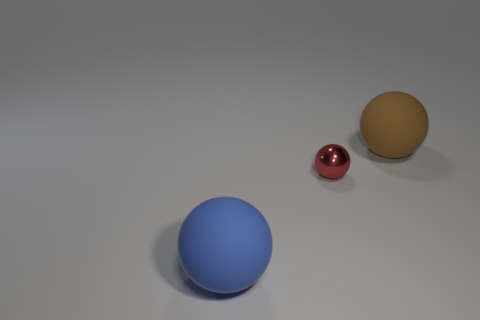Add 1 large blue matte blocks. How many objects exist? 4 Add 3 large brown things. How many large brown things are left? 4 Add 3 gray matte cylinders. How many gray matte cylinders exist? 3 Subtract 0 gray balls. How many objects are left? 3 Subtract all blue rubber things. Subtract all large gray matte cubes. How many objects are left? 2 